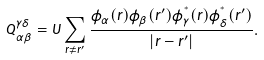<formula> <loc_0><loc_0><loc_500><loc_500>Q _ { \alpha \beta } ^ { \gamma \delta } = U \sum _ { { r } \neq { r } ^ { \prime } } \frac { \phi _ { \alpha } ( { r } ) \phi _ { \beta } ( { r } ^ { \prime } ) \phi ^ { ^ { * } } _ { \gamma } ( { r } ) \phi ^ { ^ { * } } _ { \delta } ( { r } ^ { \prime } ) } { | { r } - { r } ^ { \prime } | } .</formula> 